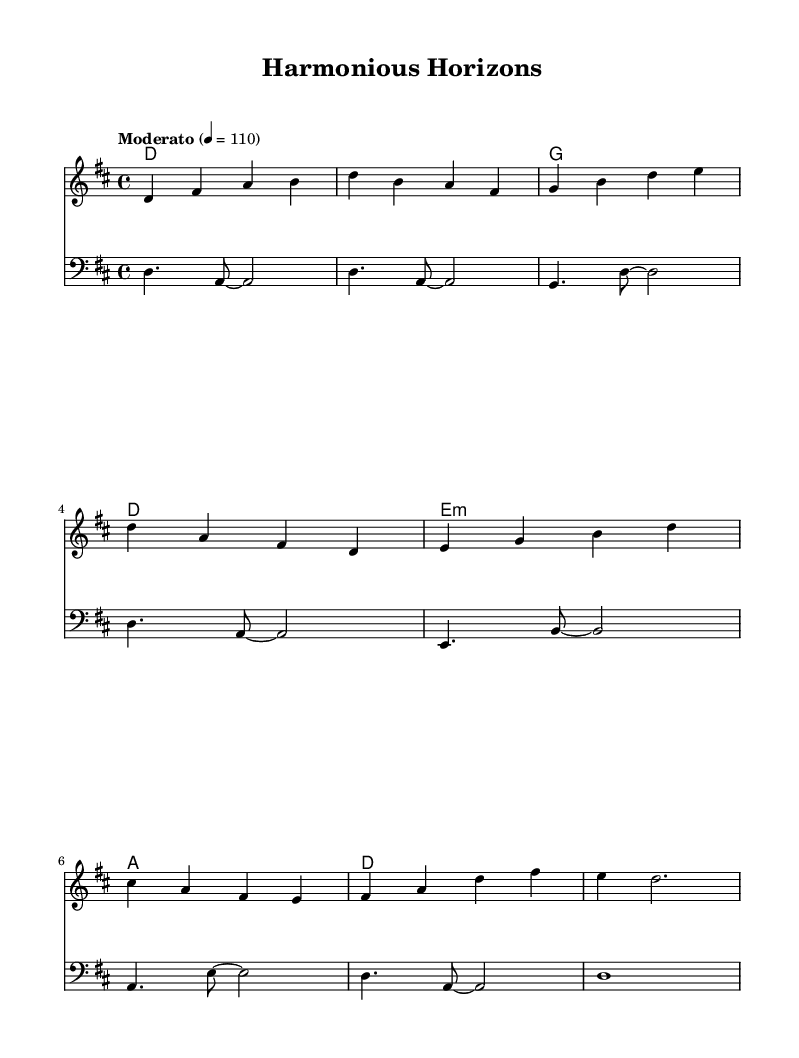What is the key signature of this music? The key signature is determined by looking at the accidentals at the beginning of the staff. In this case, there are two sharps, F# and C#. Therefore, the key signature indicates D major or B minor.
Answer: D major What is the time signature of this music? The time signature is indicated at the beginning of the piece. It is shown as a fraction, where the numerator represents the number of beats in a measure and the denominator represents the type of note that receives one beat. Here, it is marked as 4/4, meaning there are four beats per measure.
Answer: 4/4 What is the tempo indication of this music? The tempo is given at the start of the composition, marked as “Moderato” with a metronome marking of 110. This indicates the speed at which the piece should be played.
Answer: Moderato, 110 How many measures does the melody section have? Counting the bars in the melody indicates how many distinct measures are present. The melody consists of a series of measures separated by vertical lines, totaling to eight measures.
Answer: 8 What is the first chord in the harmony section? The first chord is displayed at the start of the harmony line, and it shows a D major chord signified by the letter D. This indicates what notes are played simultaneously.
Answer: D Explain the rhythmic pattern used in the bass part. The bass part shows a variety of rhythmic values, primarily using dotted half notes and eighth notes. The first measure has a dotted half note followed by two eighth notes. Observing the pattern reveals a consistent strategy of rhythmic decrease, maintaining a steady pulse in areas where the rhythm changes. This organized structure helps ground the harmonic progression throughout.
Answer: Dotted half notes and eighth notes What is the last note of the melody section? To determine the last note, one can look at the final measure of the melody. The note is a D that is held for a dotted half note duration, indicating a resolution to the piece.
Answer: D 